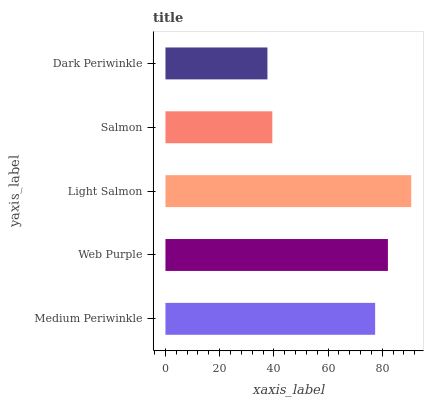Is Dark Periwinkle the minimum?
Answer yes or no. Yes. Is Light Salmon the maximum?
Answer yes or no. Yes. Is Web Purple the minimum?
Answer yes or no. No. Is Web Purple the maximum?
Answer yes or no. No. Is Web Purple greater than Medium Periwinkle?
Answer yes or no. Yes. Is Medium Periwinkle less than Web Purple?
Answer yes or no. Yes. Is Medium Periwinkle greater than Web Purple?
Answer yes or no. No. Is Web Purple less than Medium Periwinkle?
Answer yes or no. No. Is Medium Periwinkle the high median?
Answer yes or no. Yes. Is Medium Periwinkle the low median?
Answer yes or no. Yes. Is Light Salmon the high median?
Answer yes or no. No. Is Web Purple the low median?
Answer yes or no. No. 